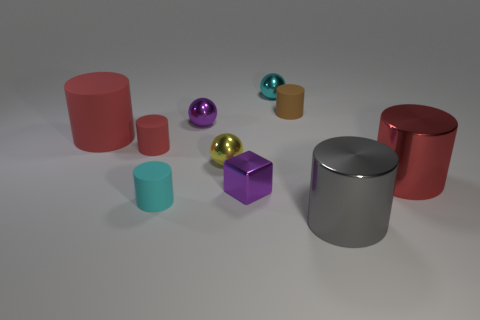What number of metal spheres have the same color as the block?
Provide a short and direct response. 1. There is a cyan thing that is behind the cyan matte cylinder; is its size the same as the red object that is on the right side of the brown matte cylinder?
Your answer should be very brief. No. What is the tiny sphere that is behind the yellow shiny thing and on the right side of the tiny purple ball made of?
Offer a very short reply. Metal. Are there any brown rubber things?
Your answer should be very brief. Yes. There is a tiny metal cube; is it the same color as the large metal object in front of the small cyan matte thing?
Your answer should be compact. No. There is a tiny object that is the same color as the large rubber thing; what is its material?
Your response must be concise. Rubber. There is a tiny cyan object in front of the large red cylinder that is on the left side of the cyan shiny thing that is on the right side of the big red rubber object; what is its shape?
Provide a succinct answer. Cylinder. The brown object is what shape?
Your answer should be compact. Cylinder. There is a big metal thing that is behind the gray object; what color is it?
Your answer should be compact. Red. There is a red cylinder on the right side of the gray metal object; does it have the same size as the tiny purple block?
Offer a very short reply. No. 